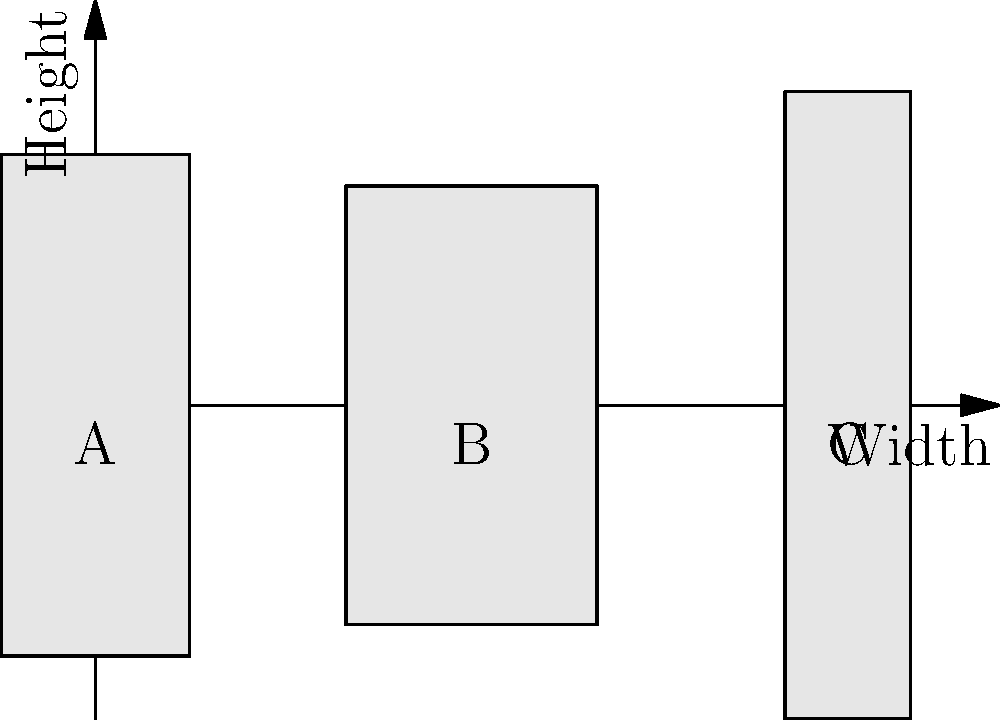As a spirits appraiser, you're presented with three uniquely shaped bottles (A, B, and C) as shown in the diagram. Assuming each bottle has a cylindrical shape, which bottle would likely hold the largest volume of spirits? To determine which bottle holds the largest volume, we need to compare their cylindrical volumes. The volume of a cylinder is given by the formula $V = \pi r^2 h$, where $r$ is the radius (half the width) and $h$ is the height.

Let's calculate the relative volumes for each bottle:

1. Bottle A:
   Height: 4 units
   Width: 1.5 units
   Radius: 0.75 units
   Relative volume: $V_A = \pi (0.75)^2 (4) = 7.07\pi$

2. Bottle B:
   Height: 3.5 units
   Width: 2 units
   Radius: 1 unit
   Relative volume: $V_B = \pi (1)^2 (3.5) = 11\pi$

3. Bottle C:
   Height: 5 units
   Width: 1 unit
   Radius: 0.5 units
   Relative volume: $V_C = \pi (0.5)^2 (5) = 3.93\pi$

Comparing these volumes, we can see that Bottle B has the largest relative volume at $11\pi$, followed by Bottle A at $7.07\pi$, and finally Bottle C at $3.93\pi$.
Answer: Bottle B 